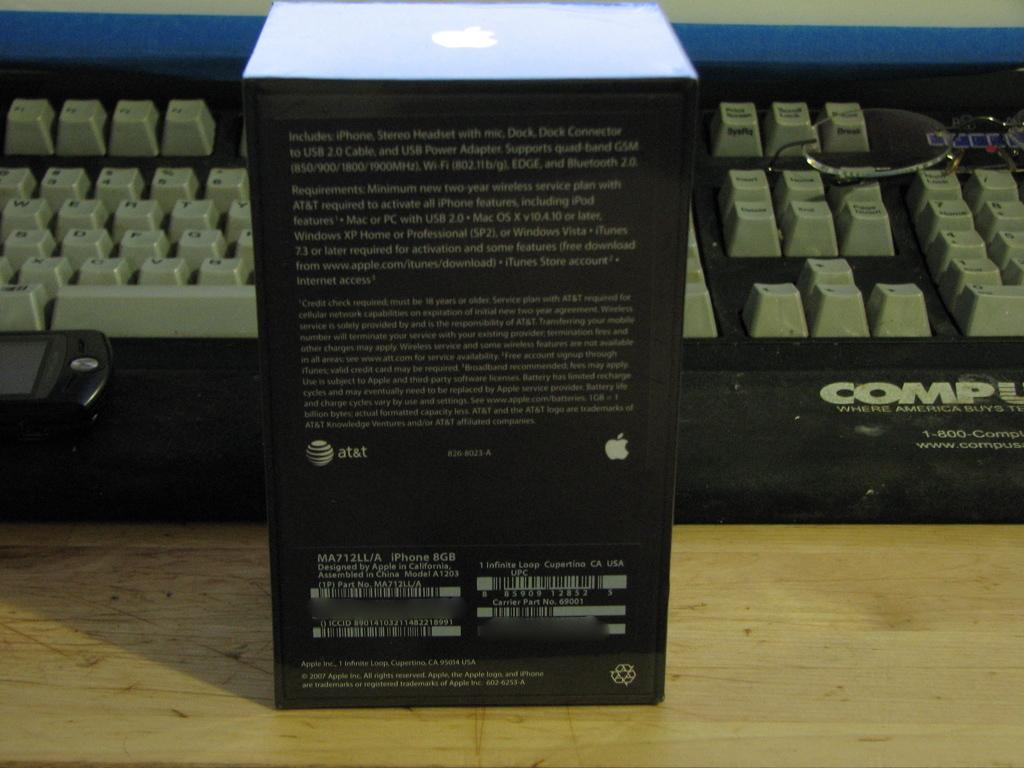<image>
Provide a brief description of the given image. A black box with an Apple product utilzing AT&T services in front of a keyboard. 